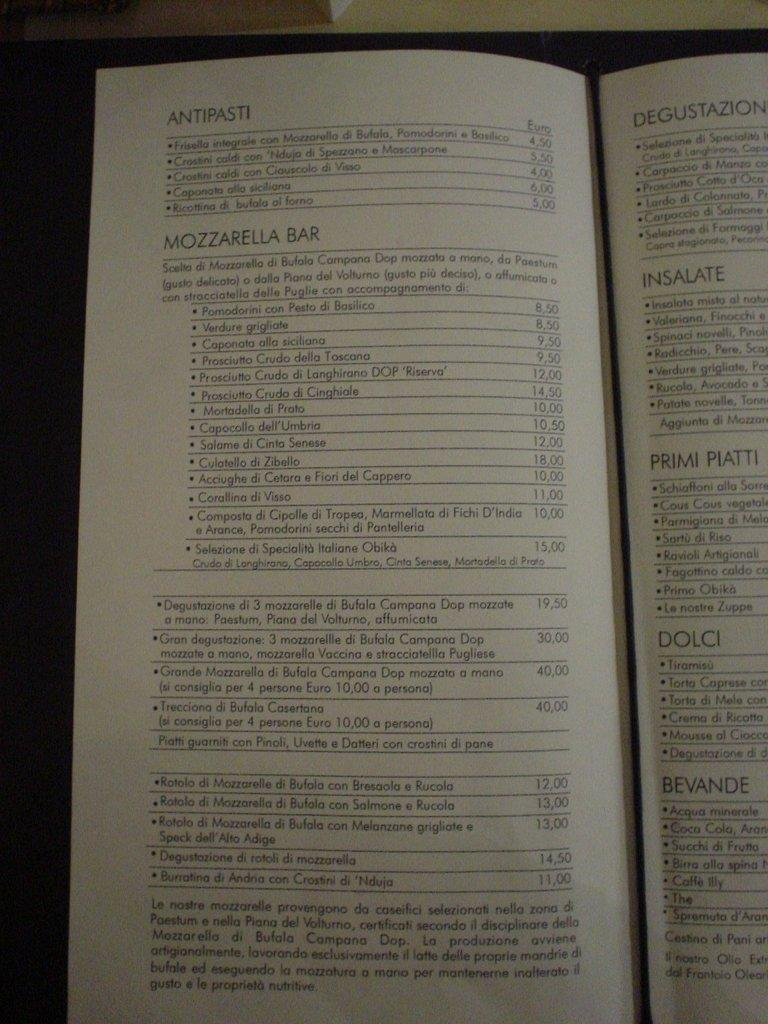<image>
Share a concise interpretation of the image provided. A menu list with the word Antipasti on top. 